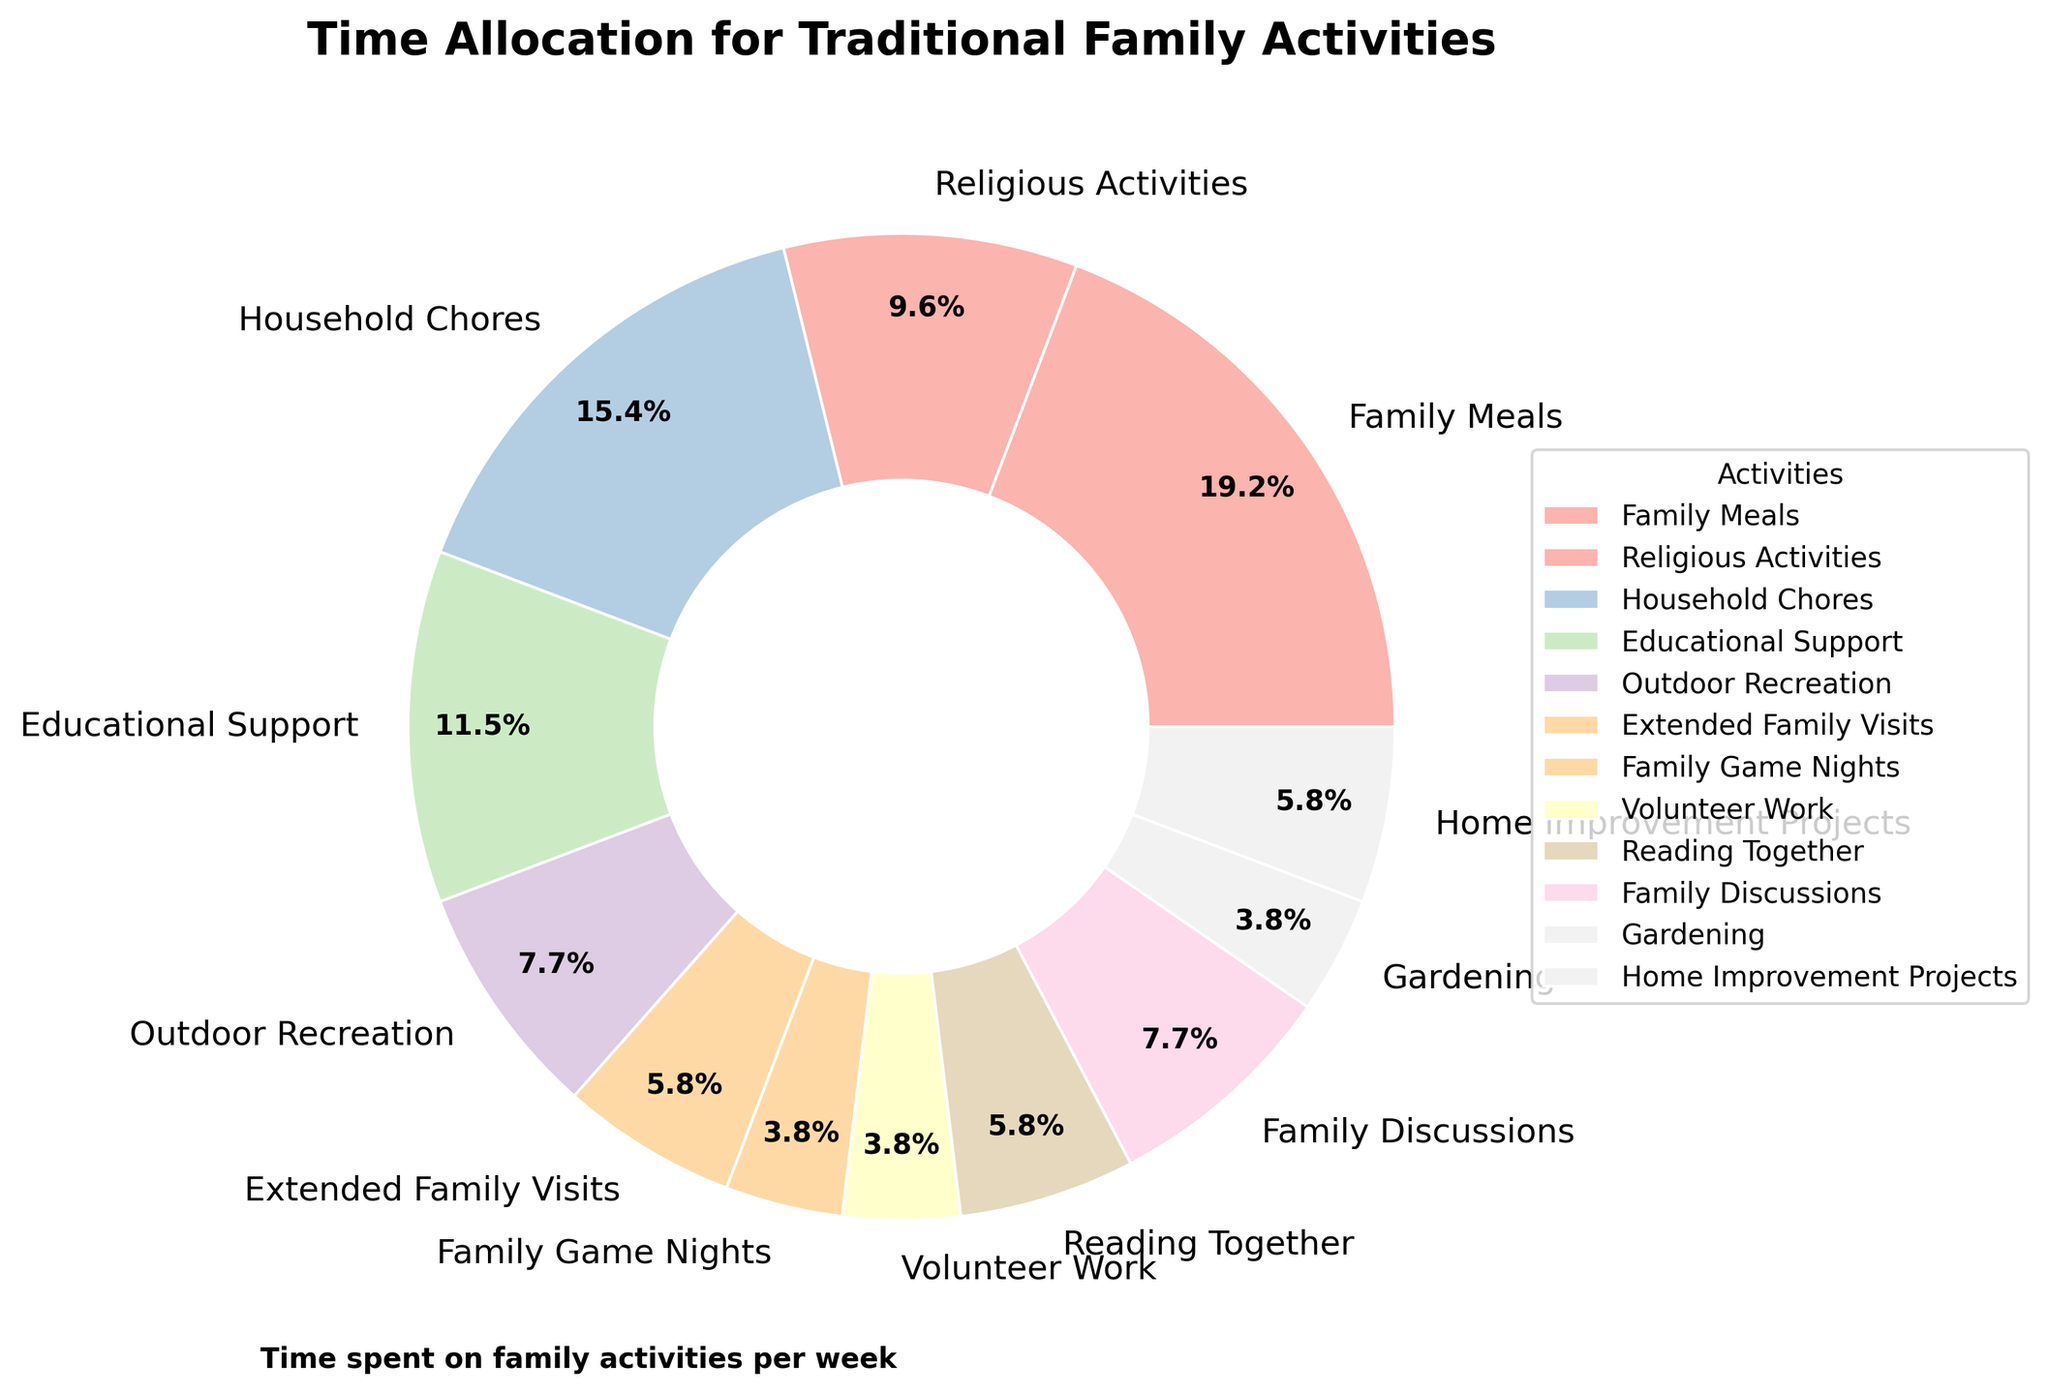Which activity consumes the most time per week? The largest segment in the pie chart corresponds to the activity 'Family Meals', indicating it consumes the most time per week.
Answer: Family Meals Which activity takes the least time per week? The smallest segment in the pie chart corresponds to activities 'Family Game Nights', 'Volunteer Work', and 'Gardening', indicating they take the least time per week.
Answer: Family Game Nights, Volunteer Work, Gardening How does the time spent on Family Meals compare to time spent on Household Chores? The segment for 'Family Meals' is larger than the segment for 'Household Chores', indicating more time is spent on Family Meals.
Answer: More time on Family Meals What is the difference in time spent between Educational Support and Outdoor Recreation? The segment for 'Educational Support' represents 6 hours, while the segment for 'Outdoor Recreation' represents 4 hours. The difference is 6 - 4 = 2 hours.
Answer: 2 hours What percentage of total weekly time is spent on Religious Activities? The pie chart indicates that Religious Activities take up 5 hours out of the total sum of all activities. The total is 52 hours (10 + 5 + 8 + 6 + 4 + 3 + 2 + 2 + 3 + 4 + 2 + 3), so the percentage is (5/52) * 100 ≈ 9.6%.
Answer: Approximately 9.6% Is the time spent on Family Meals greater than the combined time spent on Gardening and Family Game Nights? 'Family Meals' consumes 10 hours, while 'Gardening' and 'Family Game Nights' together consume 2 + 2 = 4 hours. 10 hours > 4 hours.
Answer: Yes What is the total time spent on activities involving extended family (Extended Family Visits + Family Discussions)? 'Extended Family Visits' take 3 hours and 'Family Discussions' take 4 hours. The total time is 3 + 4 = 7 hours.
Answer: 7 hours How does the sum of time spent on Household Chores and Home Improvement Projects compare to the time spent on Educational Support? The combined time for 'Household Chores' and 'Home Improvement Projects' is 8 + 3 = 11 hours. 'Educational Support' takes 6 hours. 11 hours > 6 hours.
Answer: More on Household Chores and Home Improvement Projects What fraction of time is spent on Reading Together compared to Family Meals? 'Reading Together' takes 3 hours, and 'Family Meals' take 10 hours. The fraction is 3/10.
Answer: 3/10 Which activities each account for less than 5% of the total weekly time? 'Family Game Nights', 'Volunteer Work', and 'Gardening' each take 2 hours out of the total of 52 hours. The percentage is (2/52) * 100 ≈ 3.8%.
Answer: Family Game Nights, Volunteer Work, Gardening 